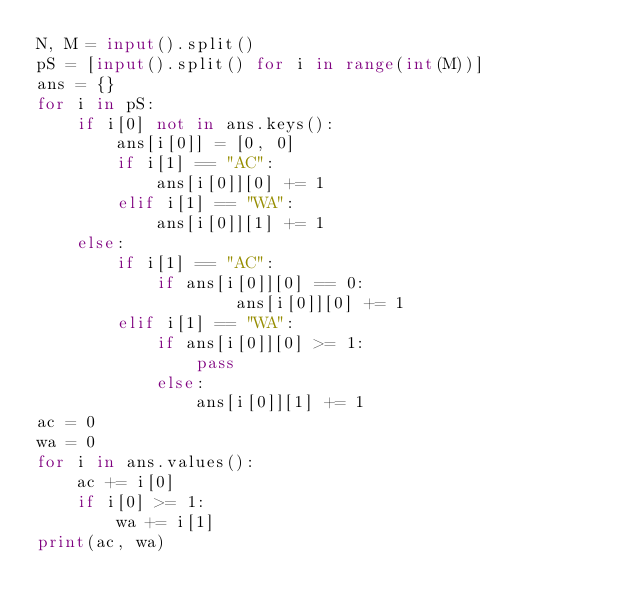<code> <loc_0><loc_0><loc_500><loc_500><_Python_>N, M = input().split()
pS = [input().split() for i in range(int(M))]
ans = {}
for i in pS:
    if i[0] not in ans.keys():
        ans[i[0]] = [0, 0]
        if i[1] == "AC":
            ans[i[0]][0] += 1
        elif i[1] == "WA":
            ans[i[0]][1] += 1
    else:
        if i[1] == "AC":
            if ans[i[0]][0] == 0:
                    ans[i[0]][0] += 1
        elif i[1] == "WA":
            if ans[i[0]][0] >= 1:
                pass
            else:
                ans[i[0]][1] += 1
ac = 0
wa = 0
for i in ans.values():
    ac += i[0]
    if i[0] >= 1:
        wa += i[1]
print(ac, wa)</code> 